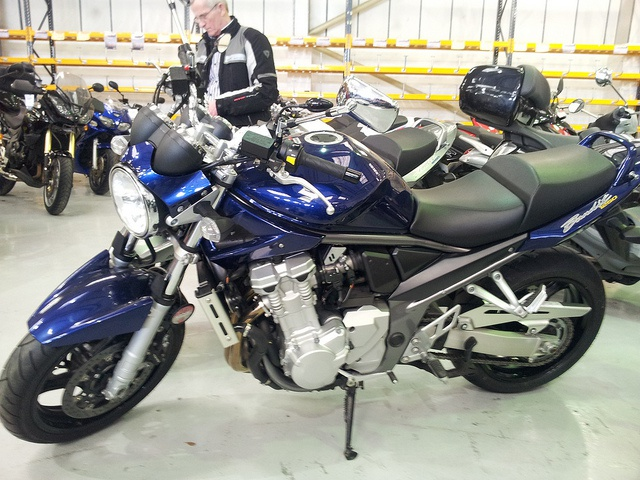Describe the objects in this image and their specific colors. I can see motorcycle in gray, black, darkgray, and navy tones, motorcycle in gray, black, darkgray, and lightgray tones, people in gray, black, and lightgray tones, motorcycle in gray, black, ivory, and darkgray tones, and motorcycle in gray, lightgray, and darkgray tones in this image. 